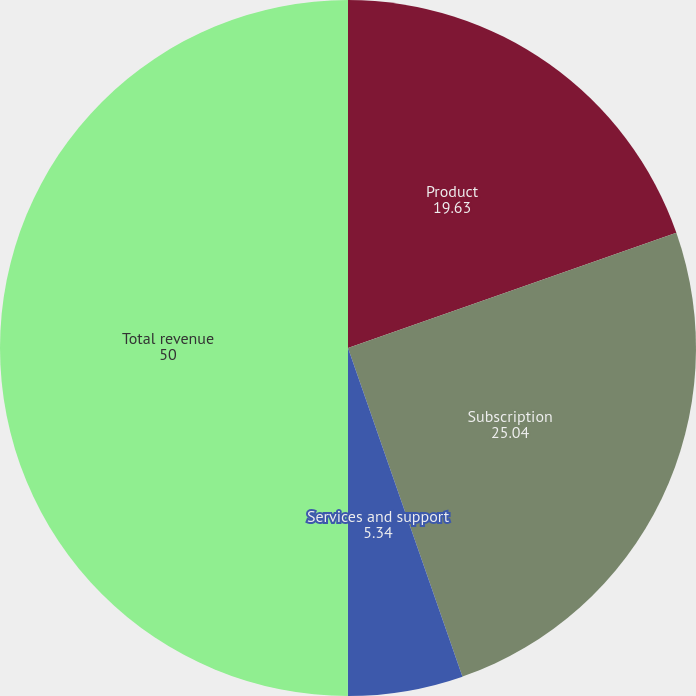Convert chart. <chart><loc_0><loc_0><loc_500><loc_500><pie_chart><fcel>Product<fcel>Subscription<fcel>Services and support<fcel>Total revenue<nl><fcel>19.63%<fcel>25.04%<fcel>5.34%<fcel>50.0%<nl></chart> 